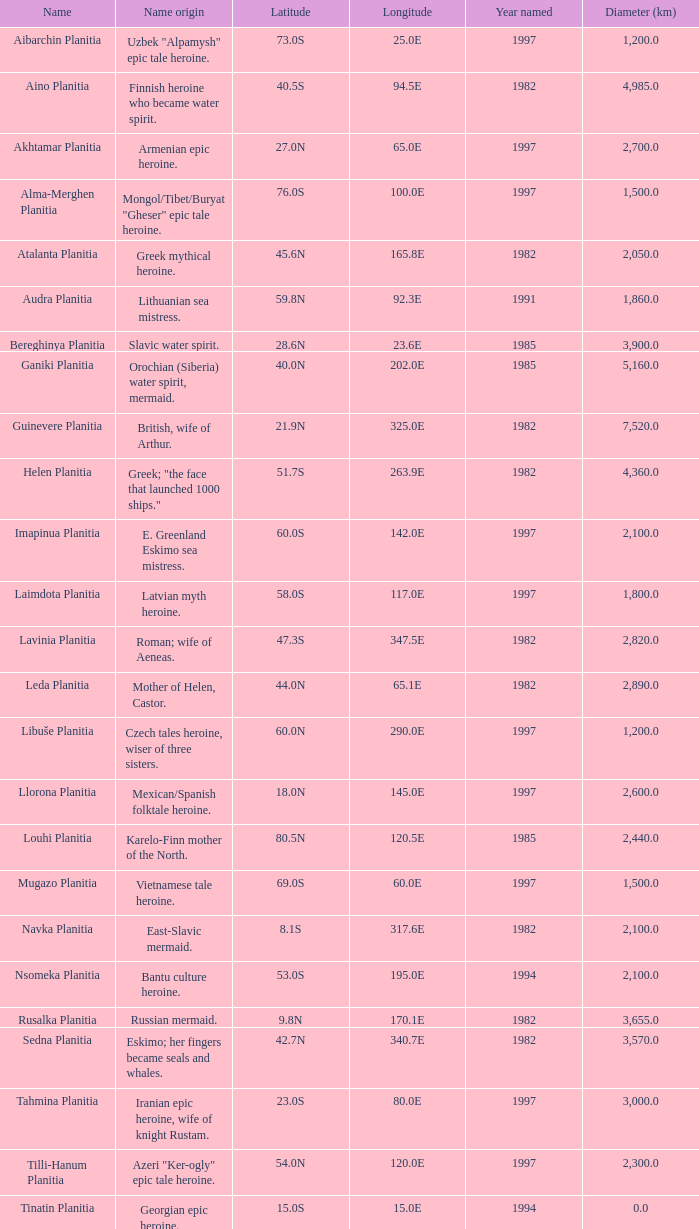What is the diameter (km) of feature of latitude 40.5s 4985.0. 